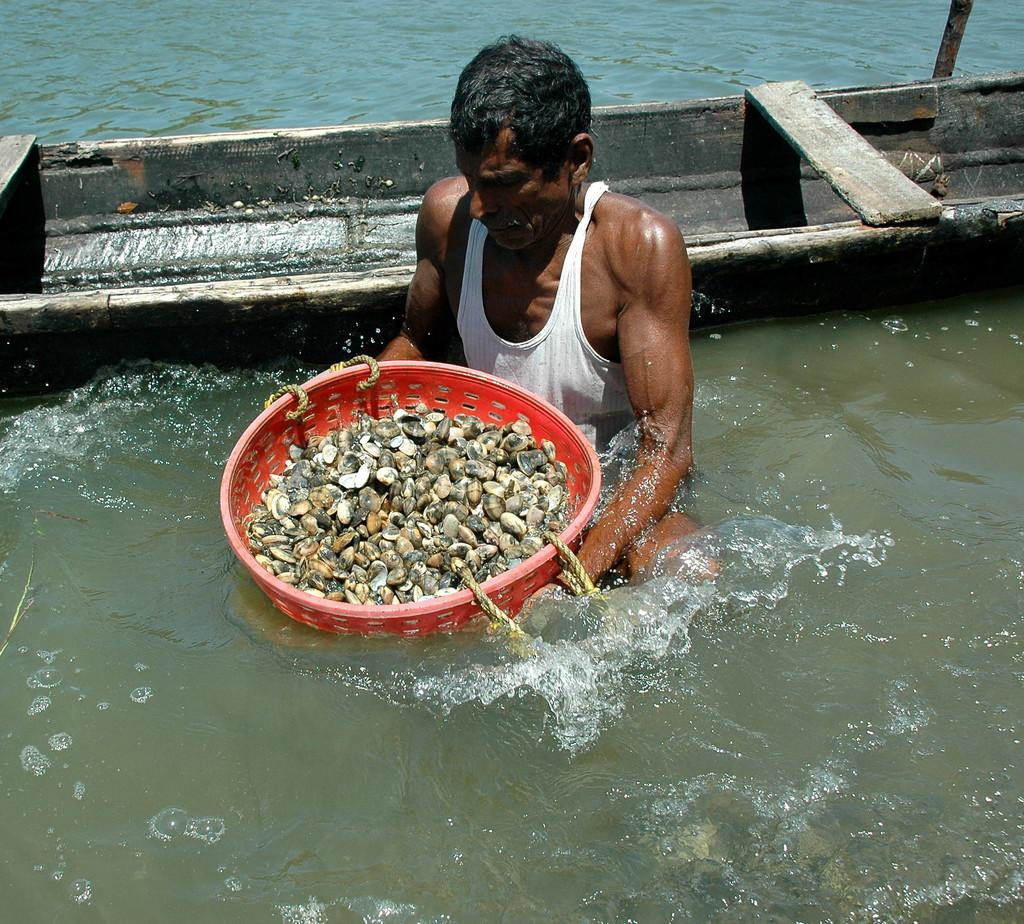What is the main element present in the image? There is water in the image. What is the man in the image doing? A man is standing in the water and holding a tub. What is inside the tub? There are shells in the tub. What can be seen behind the man? There is a boat behind the man. What language is the man giving advice in the image? There is no indication in the image that the man is giving advice or speaking any language. 